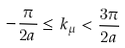<formula> <loc_0><loc_0><loc_500><loc_500>- \frac { \pi } { 2 a } \leq k _ { \mu } < \frac { 3 \pi } { 2 a }</formula> 